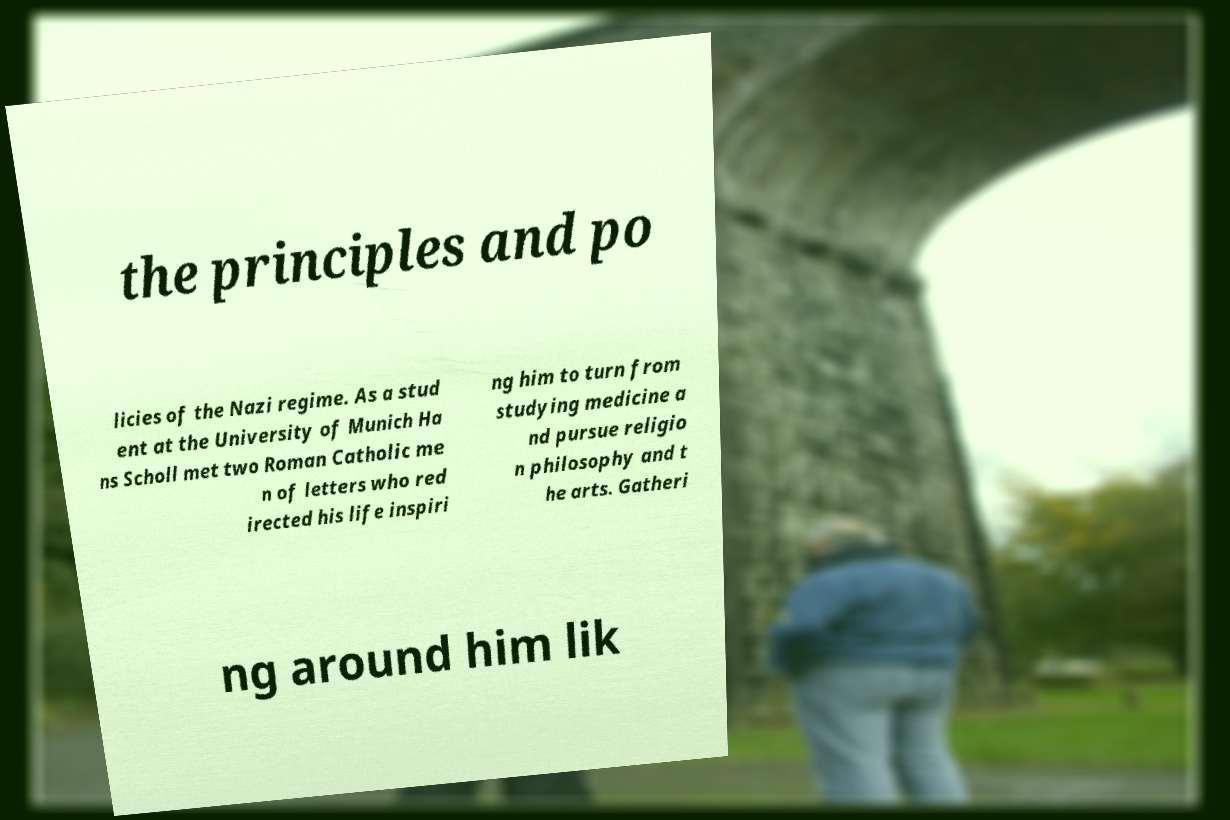Please identify and transcribe the text found in this image. the principles and po licies of the Nazi regime. As a stud ent at the University of Munich Ha ns Scholl met two Roman Catholic me n of letters who red irected his life inspiri ng him to turn from studying medicine a nd pursue religio n philosophy and t he arts. Gatheri ng around him lik 